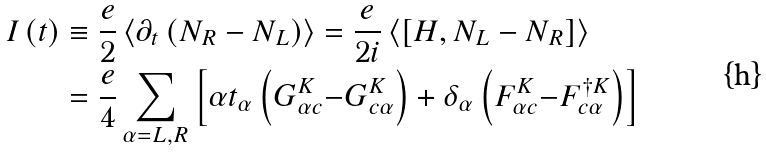<formula> <loc_0><loc_0><loc_500><loc_500>I \left ( t \right ) & \equiv \frac { e } { 2 } \left \langle \partial _ { t } \left ( N _ { R } - N _ { L } \right ) \right \rangle = \frac { e } { 2 i } \left \langle \left [ H , N _ { L } - N _ { R } \right ] \right \rangle \\ & = \frac { e } { 4 } \sum _ { \alpha = L , R } \left [ \alpha t _ { \alpha } \left ( G _ { \alpha c } ^ { K } \mathcal { - } G _ { c \alpha } ^ { K } \right ) + \delta _ { \alpha } \left ( F _ { \alpha c } ^ { K } \mathcal { - } F _ { c \alpha } ^ { \dagger K } \right ) \right ]</formula> 